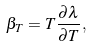<formula> <loc_0><loc_0><loc_500><loc_500>\beta _ { T } = T \frac { \partial \lambda } { \partial T } ,</formula> 